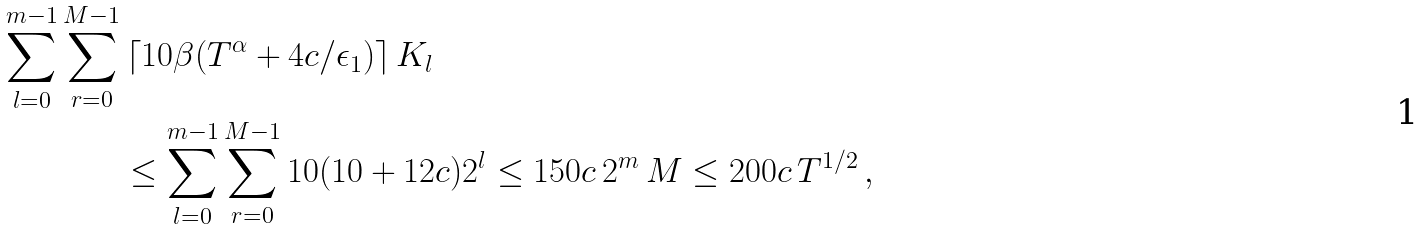Convert formula to latex. <formula><loc_0><loc_0><loc_500><loc_500>\sum _ { l = 0 } ^ { m - 1 } \sum _ { r = 0 } ^ { M - 1 } & \left \lceil 1 0 \beta ( T ^ { \alpha } + 4 c / \epsilon _ { 1 } ) \right \rceil K _ { l } \\ & \leq \sum _ { l = 0 } ^ { m - 1 } \sum _ { r = 0 } ^ { M - 1 } 1 0 ( 1 0 + 1 2 c ) 2 ^ { l } \leq 1 5 0 c \, 2 ^ { m } \, M \leq 2 0 0 c \, T ^ { 1 / 2 } \, ,</formula> 